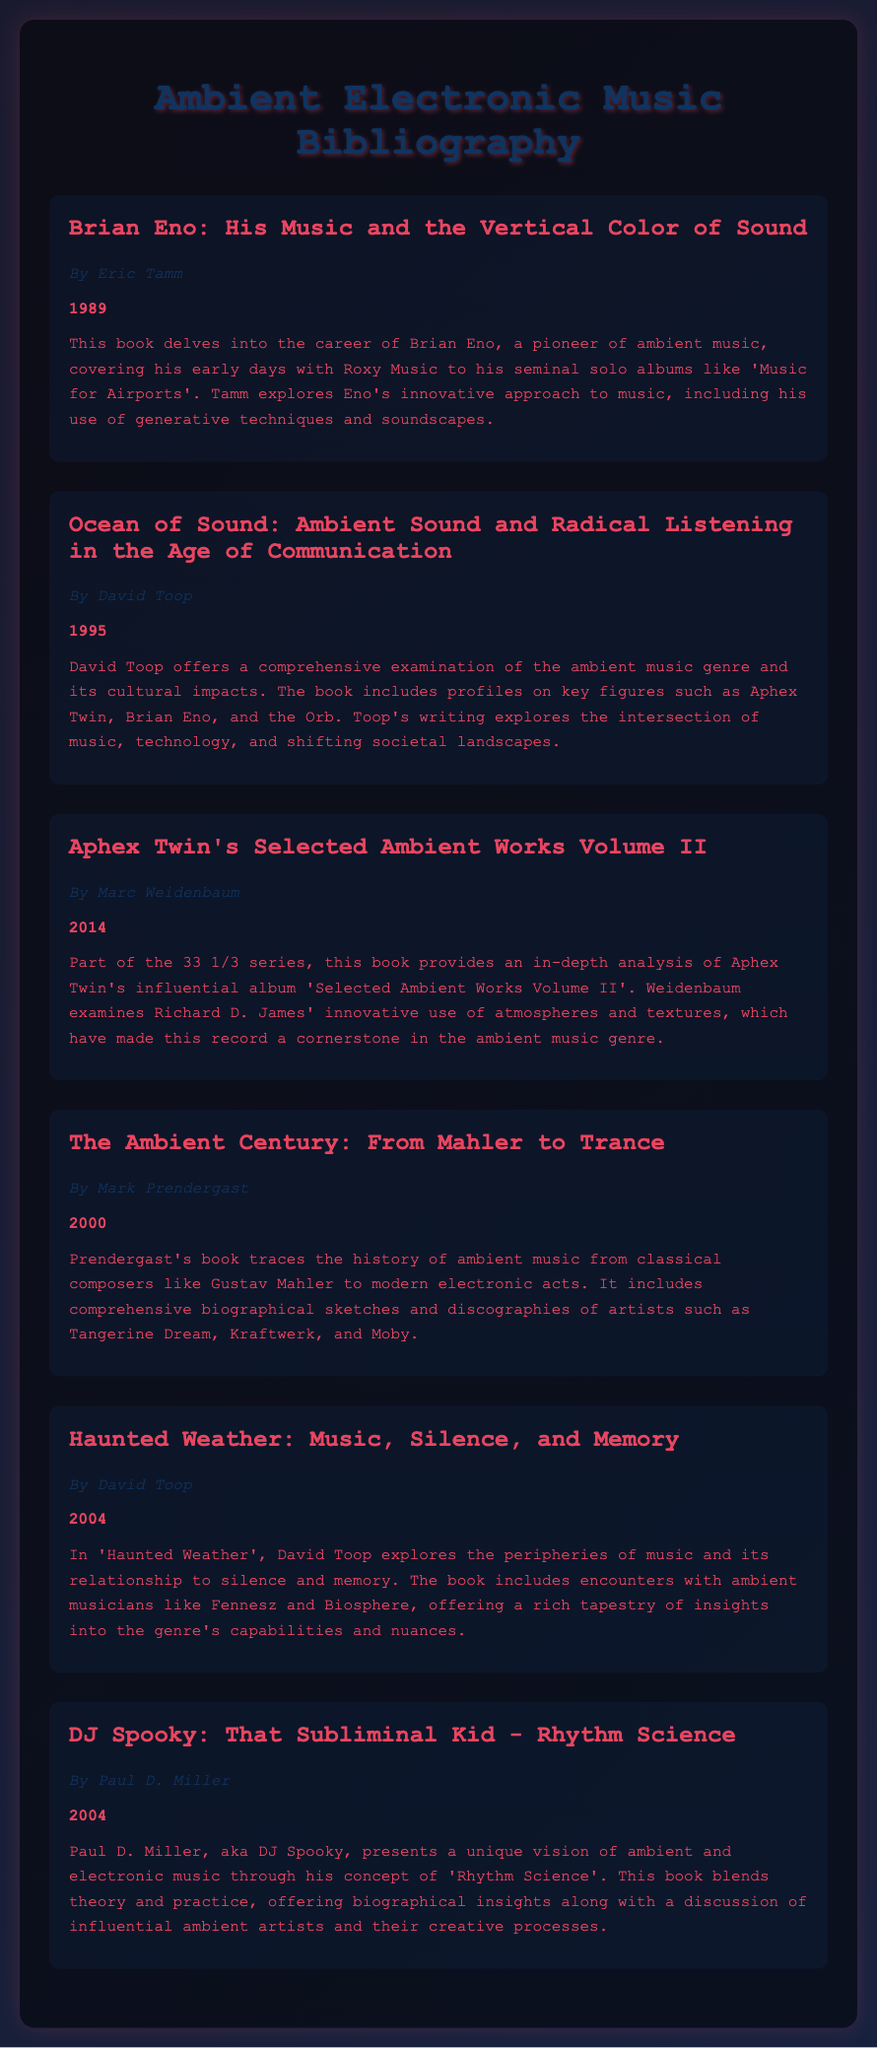what is the title of the book by Eric Tamm? The title is listed in the document under Eric Tamm's authorship.
Answer: Brian Eno: His Music and the Vertical Color of Sound who is the author of "Ocean of Sound"? The author is mentioned next to the book title in the document.
Answer: David Toop in what year was "Aphex Twin's Selected Ambient Works Volume II" published? The year of publication is clearly stated in the document next to the book title.
Answer: 2014 which musician is the focus of the book by Paul D. Miller? The document indicates the musician's name in relation to the book's title.
Answer: DJ Spooky how many books are written by David Toop? The document lists the books by David Toop, and we can count them.
Answer: 2 what genre does "The Ambient Century: From Mahler to Trance" cover? The genre is briefly mentioned in the description of the book in the document.
Answer: Ambient music which book explores the relationship between music and silence? The document specifies the topic of each book clearly, enabling identification.
Answer: Haunted Weather: Music, Silence, and Memory who authored the book focused on Brian Eno's career? The author's name is provided in conjunction with the book title in the document.
Answer: Eric Tamm what unique concept does DJ Spooky present in his book? The document indicates this unique concept in the book's summary.
Answer: Rhythm Science 